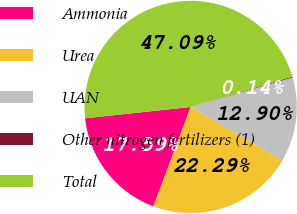<chart> <loc_0><loc_0><loc_500><loc_500><pie_chart><fcel>Ammonia<fcel>Urea<fcel>UAN<fcel>Other nitrogen fertilizers (1)<fcel>Total<nl><fcel>17.59%<fcel>22.29%<fcel>12.9%<fcel>0.14%<fcel>47.09%<nl></chart> 